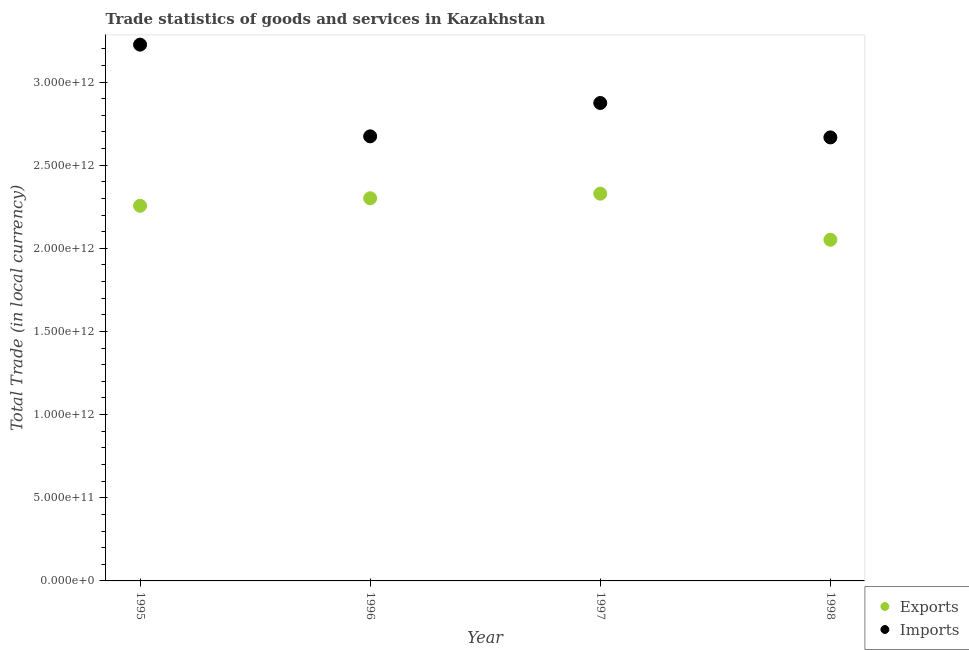Is the number of dotlines equal to the number of legend labels?
Your answer should be very brief. Yes. What is the imports of goods and services in 1996?
Your response must be concise. 2.67e+12. Across all years, what is the maximum export of goods and services?
Your response must be concise. 2.33e+12. Across all years, what is the minimum export of goods and services?
Make the answer very short. 2.05e+12. In which year was the export of goods and services maximum?
Offer a terse response. 1997. In which year was the imports of goods and services minimum?
Offer a very short reply. 1998. What is the total imports of goods and services in the graph?
Ensure brevity in your answer.  1.14e+13. What is the difference between the imports of goods and services in 1996 and that in 1997?
Ensure brevity in your answer.  -2.01e+11. What is the difference between the imports of goods and services in 1996 and the export of goods and services in 1995?
Offer a very short reply. 4.18e+11. What is the average imports of goods and services per year?
Offer a terse response. 2.86e+12. In the year 1997, what is the difference between the export of goods and services and imports of goods and services?
Your response must be concise. -5.45e+11. In how many years, is the imports of goods and services greater than 1900000000000 LCU?
Your answer should be very brief. 4. What is the ratio of the imports of goods and services in 1997 to that in 1998?
Keep it short and to the point. 1.08. Is the difference between the export of goods and services in 1996 and 1998 greater than the difference between the imports of goods and services in 1996 and 1998?
Your answer should be very brief. Yes. What is the difference between the highest and the second highest export of goods and services?
Give a very brief answer. 2.76e+1. What is the difference between the highest and the lowest export of goods and services?
Offer a terse response. 2.77e+11. In how many years, is the export of goods and services greater than the average export of goods and services taken over all years?
Your answer should be compact. 3. Does the export of goods and services monotonically increase over the years?
Offer a terse response. No. How many dotlines are there?
Ensure brevity in your answer.  2. What is the difference between two consecutive major ticks on the Y-axis?
Give a very brief answer. 5.00e+11. Does the graph contain any zero values?
Offer a terse response. No. Does the graph contain grids?
Offer a terse response. No. Where does the legend appear in the graph?
Provide a succinct answer. Bottom right. How are the legend labels stacked?
Provide a succinct answer. Vertical. What is the title of the graph?
Keep it short and to the point. Trade statistics of goods and services in Kazakhstan. What is the label or title of the X-axis?
Give a very brief answer. Year. What is the label or title of the Y-axis?
Give a very brief answer. Total Trade (in local currency). What is the Total Trade (in local currency) of Exports in 1995?
Make the answer very short. 2.26e+12. What is the Total Trade (in local currency) in Imports in 1995?
Ensure brevity in your answer.  3.22e+12. What is the Total Trade (in local currency) of Exports in 1996?
Your answer should be very brief. 2.30e+12. What is the Total Trade (in local currency) of Imports in 1996?
Provide a succinct answer. 2.67e+12. What is the Total Trade (in local currency) in Exports in 1997?
Your answer should be compact. 2.33e+12. What is the Total Trade (in local currency) in Imports in 1997?
Offer a very short reply. 2.87e+12. What is the Total Trade (in local currency) of Exports in 1998?
Keep it short and to the point. 2.05e+12. What is the Total Trade (in local currency) of Imports in 1998?
Provide a succinct answer. 2.67e+12. Across all years, what is the maximum Total Trade (in local currency) of Exports?
Give a very brief answer. 2.33e+12. Across all years, what is the maximum Total Trade (in local currency) of Imports?
Provide a succinct answer. 3.22e+12. Across all years, what is the minimum Total Trade (in local currency) in Exports?
Keep it short and to the point. 2.05e+12. Across all years, what is the minimum Total Trade (in local currency) of Imports?
Ensure brevity in your answer.  2.67e+12. What is the total Total Trade (in local currency) in Exports in the graph?
Offer a very short reply. 8.94e+12. What is the total Total Trade (in local currency) of Imports in the graph?
Your answer should be compact. 1.14e+13. What is the difference between the Total Trade (in local currency) of Exports in 1995 and that in 1996?
Provide a short and direct response. -4.51e+1. What is the difference between the Total Trade (in local currency) of Imports in 1995 and that in 1996?
Give a very brief answer. 5.51e+11. What is the difference between the Total Trade (in local currency) of Exports in 1995 and that in 1997?
Keep it short and to the point. -7.27e+1. What is the difference between the Total Trade (in local currency) of Imports in 1995 and that in 1997?
Offer a terse response. 3.51e+11. What is the difference between the Total Trade (in local currency) in Exports in 1995 and that in 1998?
Provide a short and direct response. 2.04e+11. What is the difference between the Total Trade (in local currency) of Imports in 1995 and that in 1998?
Give a very brief answer. 5.58e+11. What is the difference between the Total Trade (in local currency) in Exports in 1996 and that in 1997?
Offer a terse response. -2.76e+1. What is the difference between the Total Trade (in local currency) in Imports in 1996 and that in 1997?
Keep it short and to the point. -2.01e+11. What is the difference between the Total Trade (in local currency) of Exports in 1996 and that in 1998?
Provide a succinct answer. 2.49e+11. What is the difference between the Total Trade (in local currency) in Imports in 1996 and that in 1998?
Give a very brief answer. 6.42e+09. What is the difference between the Total Trade (in local currency) of Exports in 1997 and that in 1998?
Keep it short and to the point. 2.77e+11. What is the difference between the Total Trade (in local currency) in Imports in 1997 and that in 1998?
Your response must be concise. 2.07e+11. What is the difference between the Total Trade (in local currency) in Exports in 1995 and the Total Trade (in local currency) in Imports in 1996?
Ensure brevity in your answer.  -4.18e+11. What is the difference between the Total Trade (in local currency) in Exports in 1995 and the Total Trade (in local currency) in Imports in 1997?
Keep it short and to the point. -6.18e+11. What is the difference between the Total Trade (in local currency) in Exports in 1995 and the Total Trade (in local currency) in Imports in 1998?
Offer a very short reply. -4.11e+11. What is the difference between the Total Trade (in local currency) in Exports in 1996 and the Total Trade (in local currency) in Imports in 1997?
Your answer should be compact. -5.73e+11. What is the difference between the Total Trade (in local currency) in Exports in 1996 and the Total Trade (in local currency) in Imports in 1998?
Your answer should be compact. -3.66e+11. What is the difference between the Total Trade (in local currency) in Exports in 1997 and the Total Trade (in local currency) in Imports in 1998?
Provide a succinct answer. -3.38e+11. What is the average Total Trade (in local currency) of Exports per year?
Provide a succinct answer. 2.23e+12. What is the average Total Trade (in local currency) of Imports per year?
Your response must be concise. 2.86e+12. In the year 1995, what is the difference between the Total Trade (in local currency) in Exports and Total Trade (in local currency) in Imports?
Provide a succinct answer. -9.69e+11. In the year 1996, what is the difference between the Total Trade (in local currency) of Exports and Total Trade (in local currency) of Imports?
Your response must be concise. -3.72e+11. In the year 1997, what is the difference between the Total Trade (in local currency) in Exports and Total Trade (in local currency) in Imports?
Your answer should be very brief. -5.45e+11. In the year 1998, what is the difference between the Total Trade (in local currency) in Exports and Total Trade (in local currency) in Imports?
Your answer should be compact. -6.15e+11. What is the ratio of the Total Trade (in local currency) in Exports in 1995 to that in 1996?
Give a very brief answer. 0.98. What is the ratio of the Total Trade (in local currency) of Imports in 1995 to that in 1996?
Provide a short and direct response. 1.21. What is the ratio of the Total Trade (in local currency) in Exports in 1995 to that in 1997?
Offer a very short reply. 0.97. What is the ratio of the Total Trade (in local currency) in Imports in 1995 to that in 1997?
Offer a very short reply. 1.12. What is the ratio of the Total Trade (in local currency) of Exports in 1995 to that in 1998?
Offer a terse response. 1.1. What is the ratio of the Total Trade (in local currency) in Imports in 1995 to that in 1998?
Ensure brevity in your answer.  1.21. What is the ratio of the Total Trade (in local currency) of Imports in 1996 to that in 1997?
Keep it short and to the point. 0.93. What is the ratio of the Total Trade (in local currency) of Exports in 1996 to that in 1998?
Keep it short and to the point. 1.12. What is the ratio of the Total Trade (in local currency) of Exports in 1997 to that in 1998?
Keep it short and to the point. 1.14. What is the ratio of the Total Trade (in local currency) of Imports in 1997 to that in 1998?
Make the answer very short. 1.08. What is the difference between the highest and the second highest Total Trade (in local currency) in Exports?
Provide a succinct answer. 2.76e+1. What is the difference between the highest and the second highest Total Trade (in local currency) in Imports?
Ensure brevity in your answer.  3.51e+11. What is the difference between the highest and the lowest Total Trade (in local currency) of Exports?
Offer a very short reply. 2.77e+11. What is the difference between the highest and the lowest Total Trade (in local currency) of Imports?
Your answer should be compact. 5.58e+11. 